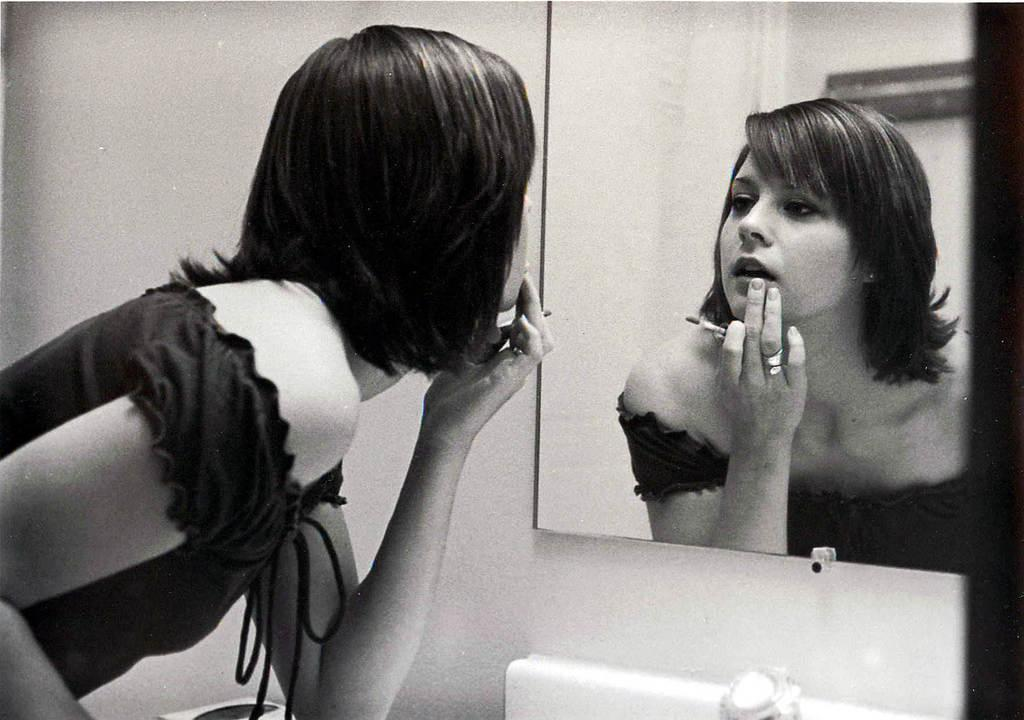Who is present in the picture? There is a woman in the picture. What object is on the wall in the picture? There is a mirror on the wall in the picture. Can you see the woman's reflection in the mirror? Yes, the woman's reflection is visible in the mirror. What is located at the bottom of the picture? There appears to be a wash basin at the bottom of the picture. How does the woman increase her speed in the image? The woman is not depicted as increasing her speed in the image. 